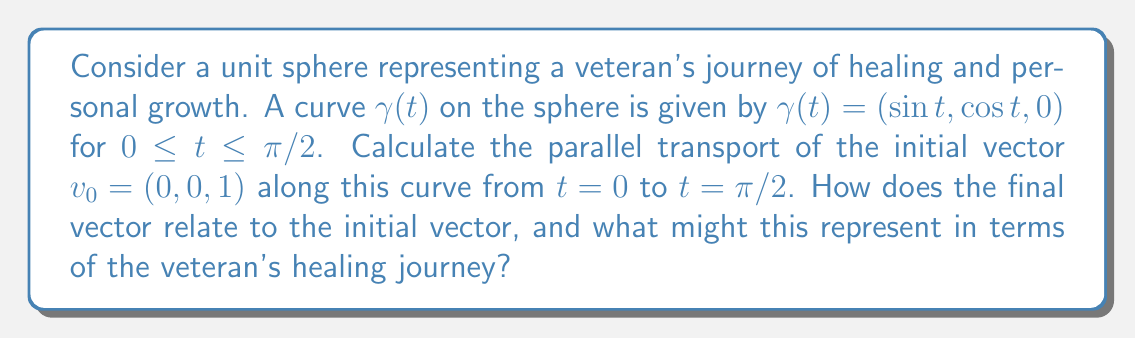Show me your answer to this math problem. To solve this problem, we'll follow these steps:

1) First, we need to calculate the tangent vector $T(t)$ to the curve:
   $$T(t) = \gamma'(t) = (\cos t, -\sin t, 0)$$

2) The normal vector $N(t)$ to the sphere at $\gamma(t)$ is:
   $$N(t) = \gamma(t) = (\sin t, \cos t, 0)$$

3) For parallel transport on a sphere, we use the formula:
   $$\frac{dv}{dt} = -\langle v, \frac{dN}{dt} \rangle N$$
   where $v$ is the vector being transported.

4) Calculate $\frac{dN}{dt}$:
   $$\frac{dN}{dt} = (\cos t, -\sin t, 0) = T(t)$$

5) Set up the differential equation:
   $$\frac{dv}{dt} = -\langle v, T(t) \rangle N(t)$$

6) Initially, $v_0 = (0, 0, 1)$, which is perpendicular to both $T(t)$ and $N(t)$ for all $t$. This means $\langle v, T(t) \rangle = 0$ for all $t$.

7) Therefore, $\frac{dv}{dt} = 0$, which means $v(t)$ remains constant throughout the transport.

8) The final vector at $t=\pi/2$ is the same as the initial vector:
   $$v(\pi/2) = v_0 = (0, 0, 1)$$

In terms of the veteran's healing journey, this result could represent the preservation of core values or inner strength throughout the process of healing and growth. Despite the journey (represented by the curve on the sphere), the fundamental essence (represented by the transported vector) remains unchanged, suggesting resilience and consistency in the face of change.
Answer: $v(\pi/2) = (0, 0, 1)$ 